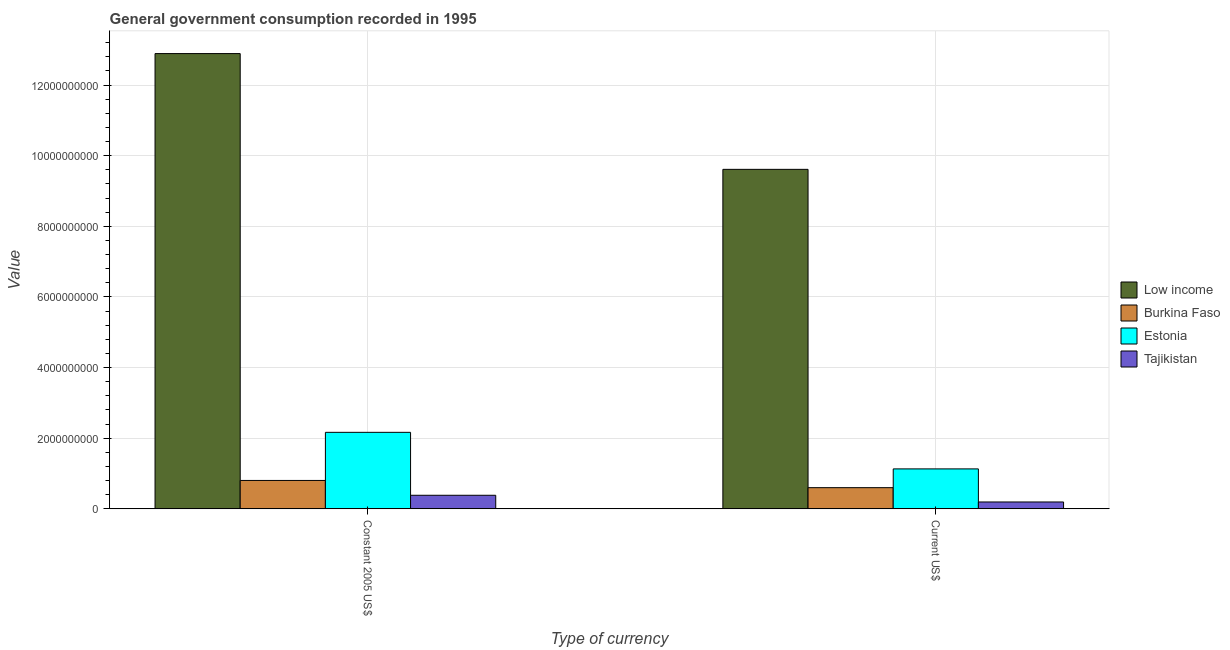How many different coloured bars are there?
Provide a short and direct response. 4. Are the number of bars per tick equal to the number of legend labels?
Keep it short and to the point. Yes. Are the number of bars on each tick of the X-axis equal?
Your answer should be very brief. Yes. How many bars are there on the 2nd tick from the left?
Give a very brief answer. 4. What is the label of the 1st group of bars from the left?
Your answer should be compact. Constant 2005 US$. What is the value consumed in current us$ in Estonia?
Offer a very short reply. 1.13e+09. Across all countries, what is the maximum value consumed in current us$?
Your answer should be very brief. 9.61e+09. Across all countries, what is the minimum value consumed in current us$?
Offer a very short reply. 1.95e+08. In which country was the value consumed in current us$ maximum?
Ensure brevity in your answer.  Low income. In which country was the value consumed in constant 2005 us$ minimum?
Your answer should be very brief. Tajikistan. What is the total value consumed in current us$ in the graph?
Keep it short and to the point. 1.15e+1. What is the difference between the value consumed in constant 2005 us$ in Low income and that in Estonia?
Provide a short and direct response. 1.07e+1. What is the difference between the value consumed in constant 2005 us$ in Burkina Faso and the value consumed in current us$ in Low income?
Ensure brevity in your answer.  -8.81e+09. What is the average value consumed in current us$ per country?
Offer a terse response. 2.88e+09. What is the difference between the value consumed in current us$ and value consumed in constant 2005 us$ in Tajikistan?
Offer a terse response. -1.90e+08. What is the ratio of the value consumed in current us$ in Burkina Faso to that in Low income?
Provide a succinct answer. 0.06. In how many countries, is the value consumed in current us$ greater than the average value consumed in current us$ taken over all countries?
Give a very brief answer. 1. What does the 2nd bar from the left in Constant 2005 US$ represents?
Your answer should be compact. Burkina Faso. What does the 2nd bar from the right in Constant 2005 US$ represents?
Your answer should be very brief. Estonia. How many bars are there?
Give a very brief answer. 8. Are all the bars in the graph horizontal?
Make the answer very short. No. Does the graph contain any zero values?
Your response must be concise. No. How many legend labels are there?
Make the answer very short. 4. What is the title of the graph?
Offer a very short reply. General government consumption recorded in 1995. Does "Comoros" appear as one of the legend labels in the graph?
Your answer should be very brief. No. What is the label or title of the X-axis?
Offer a very short reply. Type of currency. What is the label or title of the Y-axis?
Offer a terse response. Value. What is the Value in Low income in Constant 2005 US$?
Offer a very short reply. 1.29e+1. What is the Value of Burkina Faso in Constant 2005 US$?
Keep it short and to the point. 8.04e+08. What is the Value in Estonia in Constant 2005 US$?
Your answer should be compact. 2.17e+09. What is the Value of Tajikistan in Constant 2005 US$?
Your answer should be compact. 3.84e+08. What is the Value of Low income in Current US$?
Make the answer very short. 9.61e+09. What is the Value in Burkina Faso in Current US$?
Your answer should be compact. 6.00e+08. What is the Value of Estonia in Current US$?
Keep it short and to the point. 1.13e+09. What is the Value of Tajikistan in Current US$?
Offer a very short reply. 1.95e+08. Across all Type of currency, what is the maximum Value in Low income?
Your response must be concise. 1.29e+1. Across all Type of currency, what is the maximum Value of Burkina Faso?
Provide a short and direct response. 8.04e+08. Across all Type of currency, what is the maximum Value of Estonia?
Your response must be concise. 2.17e+09. Across all Type of currency, what is the maximum Value of Tajikistan?
Give a very brief answer. 3.84e+08. Across all Type of currency, what is the minimum Value of Low income?
Your answer should be very brief. 9.61e+09. Across all Type of currency, what is the minimum Value of Burkina Faso?
Provide a succinct answer. 6.00e+08. Across all Type of currency, what is the minimum Value of Estonia?
Provide a succinct answer. 1.13e+09. Across all Type of currency, what is the minimum Value of Tajikistan?
Provide a short and direct response. 1.95e+08. What is the total Value in Low income in the graph?
Your answer should be compact. 2.25e+1. What is the total Value in Burkina Faso in the graph?
Provide a short and direct response. 1.40e+09. What is the total Value of Estonia in the graph?
Keep it short and to the point. 3.30e+09. What is the total Value in Tajikistan in the graph?
Keep it short and to the point. 5.79e+08. What is the difference between the Value of Low income in Constant 2005 US$ and that in Current US$?
Ensure brevity in your answer.  3.28e+09. What is the difference between the Value of Burkina Faso in Constant 2005 US$ and that in Current US$?
Your answer should be very brief. 2.05e+08. What is the difference between the Value in Estonia in Constant 2005 US$ and that in Current US$?
Give a very brief answer. 1.04e+09. What is the difference between the Value of Tajikistan in Constant 2005 US$ and that in Current US$?
Make the answer very short. 1.90e+08. What is the difference between the Value of Low income in Constant 2005 US$ and the Value of Burkina Faso in Current US$?
Ensure brevity in your answer.  1.23e+1. What is the difference between the Value in Low income in Constant 2005 US$ and the Value in Estonia in Current US$?
Make the answer very short. 1.18e+1. What is the difference between the Value in Low income in Constant 2005 US$ and the Value in Tajikistan in Current US$?
Your response must be concise. 1.27e+1. What is the difference between the Value of Burkina Faso in Constant 2005 US$ and the Value of Estonia in Current US$?
Keep it short and to the point. -3.27e+08. What is the difference between the Value in Burkina Faso in Constant 2005 US$ and the Value in Tajikistan in Current US$?
Keep it short and to the point. 6.10e+08. What is the difference between the Value of Estonia in Constant 2005 US$ and the Value of Tajikistan in Current US$?
Keep it short and to the point. 1.97e+09. What is the average Value of Low income per Type of currency?
Keep it short and to the point. 1.13e+1. What is the average Value of Burkina Faso per Type of currency?
Your answer should be very brief. 7.02e+08. What is the average Value in Estonia per Type of currency?
Your answer should be compact. 1.65e+09. What is the average Value of Tajikistan per Type of currency?
Give a very brief answer. 2.89e+08. What is the difference between the Value in Low income and Value in Burkina Faso in Constant 2005 US$?
Your response must be concise. 1.21e+1. What is the difference between the Value in Low income and Value in Estonia in Constant 2005 US$?
Make the answer very short. 1.07e+1. What is the difference between the Value of Low income and Value of Tajikistan in Constant 2005 US$?
Provide a succinct answer. 1.25e+1. What is the difference between the Value of Burkina Faso and Value of Estonia in Constant 2005 US$?
Offer a very short reply. -1.36e+09. What is the difference between the Value in Burkina Faso and Value in Tajikistan in Constant 2005 US$?
Offer a very short reply. 4.20e+08. What is the difference between the Value of Estonia and Value of Tajikistan in Constant 2005 US$?
Ensure brevity in your answer.  1.78e+09. What is the difference between the Value of Low income and Value of Burkina Faso in Current US$?
Keep it short and to the point. 9.01e+09. What is the difference between the Value in Low income and Value in Estonia in Current US$?
Ensure brevity in your answer.  8.48e+09. What is the difference between the Value of Low income and Value of Tajikistan in Current US$?
Offer a terse response. 9.42e+09. What is the difference between the Value in Burkina Faso and Value in Estonia in Current US$?
Provide a succinct answer. -5.32e+08. What is the difference between the Value in Burkina Faso and Value in Tajikistan in Current US$?
Your answer should be very brief. 4.05e+08. What is the difference between the Value of Estonia and Value of Tajikistan in Current US$?
Your response must be concise. 9.37e+08. What is the ratio of the Value in Low income in Constant 2005 US$ to that in Current US$?
Provide a short and direct response. 1.34. What is the ratio of the Value in Burkina Faso in Constant 2005 US$ to that in Current US$?
Provide a succinct answer. 1.34. What is the ratio of the Value of Estonia in Constant 2005 US$ to that in Current US$?
Ensure brevity in your answer.  1.91. What is the ratio of the Value in Tajikistan in Constant 2005 US$ to that in Current US$?
Make the answer very short. 1.97. What is the difference between the highest and the second highest Value in Low income?
Keep it short and to the point. 3.28e+09. What is the difference between the highest and the second highest Value of Burkina Faso?
Offer a terse response. 2.05e+08. What is the difference between the highest and the second highest Value of Estonia?
Make the answer very short. 1.04e+09. What is the difference between the highest and the second highest Value in Tajikistan?
Offer a very short reply. 1.90e+08. What is the difference between the highest and the lowest Value in Low income?
Keep it short and to the point. 3.28e+09. What is the difference between the highest and the lowest Value in Burkina Faso?
Offer a very short reply. 2.05e+08. What is the difference between the highest and the lowest Value of Estonia?
Give a very brief answer. 1.04e+09. What is the difference between the highest and the lowest Value of Tajikistan?
Give a very brief answer. 1.90e+08. 